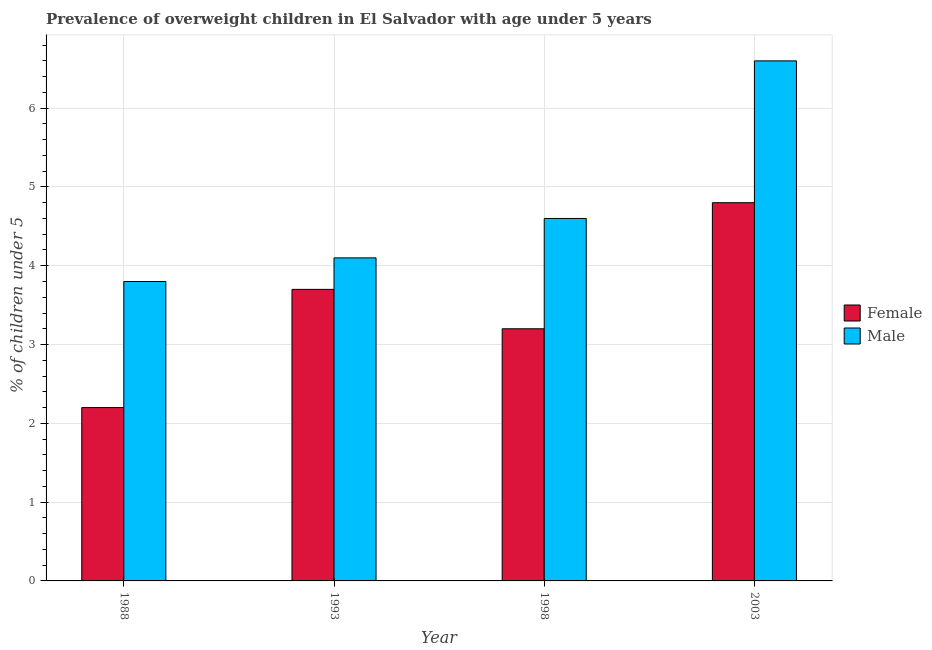How many different coloured bars are there?
Make the answer very short. 2. How many groups of bars are there?
Your response must be concise. 4. Are the number of bars per tick equal to the number of legend labels?
Ensure brevity in your answer.  Yes. Are the number of bars on each tick of the X-axis equal?
Your answer should be very brief. Yes. How many bars are there on the 2nd tick from the left?
Your response must be concise. 2. In how many cases, is the number of bars for a given year not equal to the number of legend labels?
Give a very brief answer. 0. What is the percentage of obese female children in 1988?
Provide a succinct answer. 2.2. Across all years, what is the maximum percentage of obese male children?
Keep it short and to the point. 6.6. Across all years, what is the minimum percentage of obese male children?
Make the answer very short. 3.8. What is the total percentage of obese male children in the graph?
Offer a terse response. 19.1. What is the difference between the percentage of obese male children in 1988 and that in 1998?
Your answer should be compact. -0.8. What is the difference between the percentage of obese male children in 1993 and the percentage of obese female children in 1998?
Provide a succinct answer. -0.5. What is the average percentage of obese female children per year?
Your answer should be very brief. 3.48. In how many years, is the percentage of obese female children greater than 0.8 %?
Give a very brief answer. 4. What is the ratio of the percentage of obese female children in 1988 to that in 1993?
Offer a terse response. 0.59. Is the percentage of obese male children in 1988 less than that in 1998?
Keep it short and to the point. Yes. What is the difference between the highest and the second highest percentage of obese female children?
Your answer should be compact. 1.1. What is the difference between the highest and the lowest percentage of obese female children?
Your answer should be compact. 2.6. In how many years, is the percentage of obese male children greater than the average percentage of obese male children taken over all years?
Make the answer very short. 1. Is the sum of the percentage of obese female children in 1988 and 2003 greater than the maximum percentage of obese male children across all years?
Your answer should be very brief. Yes. What does the 1st bar from the right in 1988 represents?
Offer a very short reply. Male. How many bars are there?
Give a very brief answer. 8. What is the difference between two consecutive major ticks on the Y-axis?
Ensure brevity in your answer.  1. Does the graph contain grids?
Offer a terse response. Yes. How are the legend labels stacked?
Offer a terse response. Vertical. What is the title of the graph?
Keep it short and to the point. Prevalence of overweight children in El Salvador with age under 5 years. What is the label or title of the X-axis?
Offer a terse response. Year. What is the label or title of the Y-axis?
Offer a terse response.  % of children under 5. What is the  % of children under 5 in Female in 1988?
Ensure brevity in your answer.  2.2. What is the  % of children under 5 of Male in 1988?
Your response must be concise. 3.8. What is the  % of children under 5 of Female in 1993?
Offer a very short reply. 3.7. What is the  % of children under 5 in Male in 1993?
Provide a succinct answer. 4.1. What is the  % of children under 5 in Female in 1998?
Make the answer very short. 3.2. What is the  % of children under 5 of Male in 1998?
Keep it short and to the point. 4.6. What is the  % of children under 5 in Female in 2003?
Provide a succinct answer. 4.8. What is the  % of children under 5 in Male in 2003?
Ensure brevity in your answer.  6.6. Across all years, what is the maximum  % of children under 5 of Female?
Make the answer very short. 4.8. Across all years, what is the maximum  % of children under 5 in Male?
Your response must be concise. 6.6. Across all years, what is the minimum  % of children under 5 of Female?
Offer a very short reply. 2.2. Across all years, what is the minimum  % of children under 5 in Male?
Offer a terse response. 3.8. What is the difference between the  % of children under 5 of Female in 1988 and that in 1993?
Offer a terse response. -1.5. What is the difference between the  % of children under 5 in Female in 1988 and that in 1998?
Provide a short and direct response. -1. What is the difference between the  % of children under 5 of Male in 1988 and that in 1998?
Offer a terse response. -0.8. What is the difference between the  % of children under 5 in Female in 1988 and that in 2003?
Keep it short and to the point. -2.6. What is the difference between the  % of children under 5 of Male in 1988 and that in 2003?
Make the answer very short. -2.8. What is the difference between the  % of children under 5 in Female in 1993 and that in 2003?
Your response must be concise. -1.1. What is the difference between the  % of children under 5 of Male in 1993 and that in 2003?
Give a very brief answer. -2.5. What is the difference between the  % of children under 5 of Female in 1998 and that in 2003?
Ensure brevity in your answer.  -1.6. What is the difference between the  % of children under 5 in Female in 1988 and the  % of children under 5 in Male in 1993?
Keep it short and to the point. -1.9. What is the difference between the  % of children under 5 of Female in 1993 and the  % of children under 5 of Male in 1998?
Offer a very short reply. -0.9. What is the difference between the  % of children under 5 of Female in 1993 and the  % of children under 5 of Male in 2003?
Provide a short and direct response. -2.9. What is the difference between the  % of children under 5 in Female in 1998 and the  % of children under 5 in Male in 2003?
Keep it short and to the point. -3.4. What is the average  % of children under 5 of Female per year?
Your answer should be compact. 3.48. What is the average  % of children under 5 in Male per year?
Ensure brevity in your answer.  4.78. In the year 1988, what is the difference between the  % of children under 5 of Female and  % of children under 5 of Male?
Offer a very short reply. -1.6. In the year 1998, what is the difference between the  % of children under 5 in Female and  % of children under 5 in Male?
Offer a terse response. -1.4. In the year 2003, what is the difference between the  % of children under 5 of Female and  % of children under 5 of Male?
Provide a succinct answer. -1.8. What is the ratio of the  % of children under 5 of Female in 1988 to that in 1993?
Your answer should be compact. 0.59. What is the ratio of the  % of children under 5 in Male in 1988 to that in 1993?
Keep it short and to the point. 0.93. What is the ratio of the  % of children under 5 of Female in 1988 to that in 1998?
Provide a short and direct response. 0.69. What is the ratio of the  % of children under 5 in Male in 1988 to that in 1998?
Your answer should be compact. 0.83. What is the ratio of the  % of children under 5 in Female in 1988 to that in 2003?
Provide a succinct answer. 0.46. What is the ratio of the  % of children under 5 of Male in 1988 to that in 2003?
Ensure brevity in your answer.  0.58. What is the ratio of the  % of children under 5 in Female in 1993 to that in 1998?
Keep it short and to the point. 1.16. What is the ratio of the  % of children under 5 of Male in 1993 to that in 1998?
Offer a very short reply. 0.89. What is the ratio of the  % of children under 5 of Female in 1993 to that in 2003?
Make the answer very short. 0.77. What is the ratio of the  % of children under 5 in Male in 1993 to that in 2003?
Your answer should be very brief. 0.62. What is the ratio of the  % of children under 5 in Female in 1998 to that in 2003?
Ensure brevity in your answer.  0.67. What is the ratio of the  % of children under 5 of Male in 1998 to that in 2003?
Offer a very short reply. 0.7. What is the difference between the highest and the second highest  % of children under 5 of Male?
Offer a terse response. 2. What is the difference between the highest and the lowest  % of children under 5 of Female?
Provide a succinct answer. 2.6. What is the difference between the highest and the lowest  % of children under 5 of Male?
Your answer should be very brief. 2.8. 